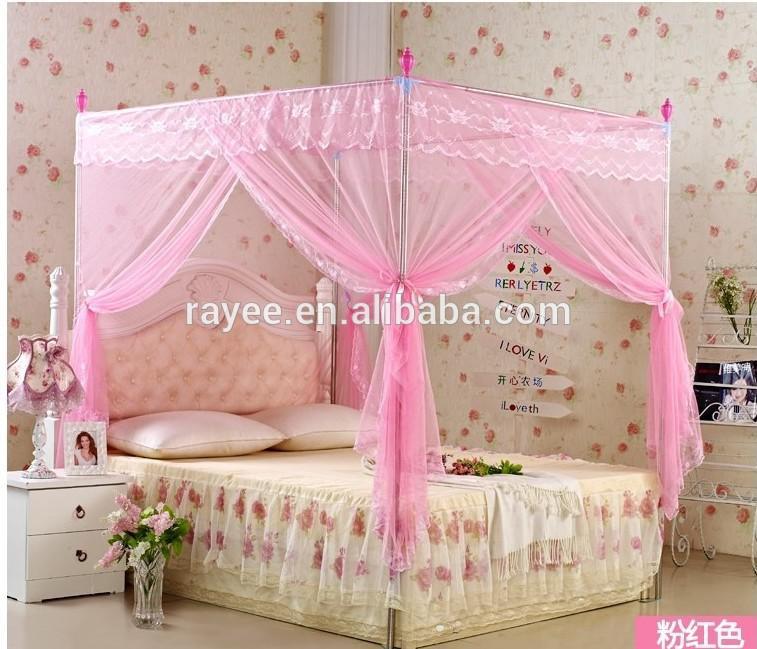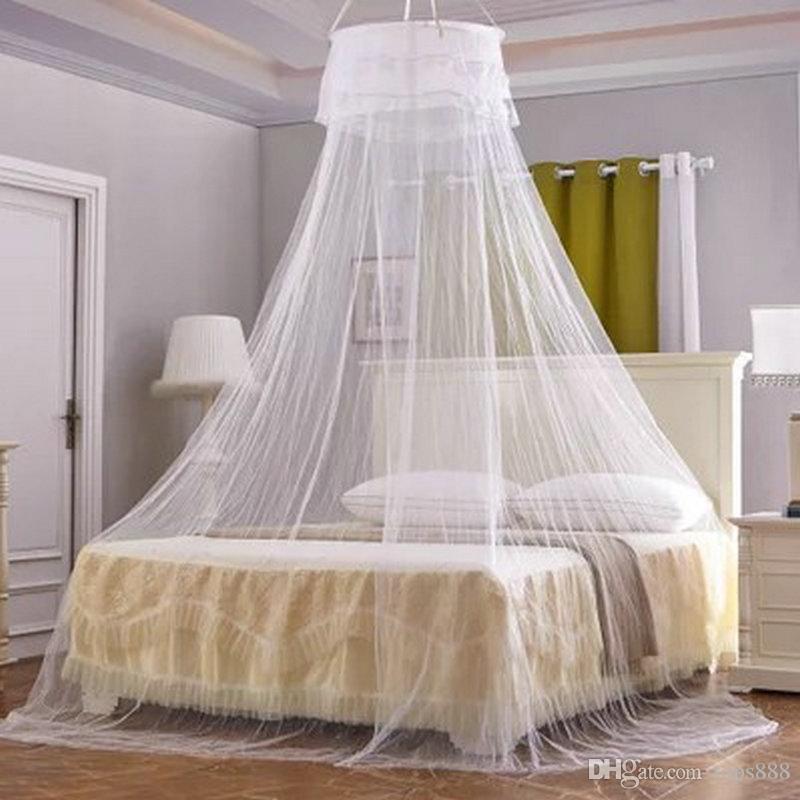The first image is the image on the left, the second image is the image on the right. Examine the images to the left and right. Is the description "There is a pink canopy hanging over a bed" accurate? Answer yes or no. Yes. The first image is the image on the left, the second image is the image on the right. Assess this claim about the two images: "The bed set in the left image has a pink canopy above it.". Correct or not? Answer yes or no. Yes. 